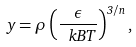Convert formula to latex. <formula><loc_0><loc_0><loc_500><loc_500>y = \rho \left ( \frac { \epsilon } { \ k B T } \right ) ^ { 3 / n } ,</formula> 